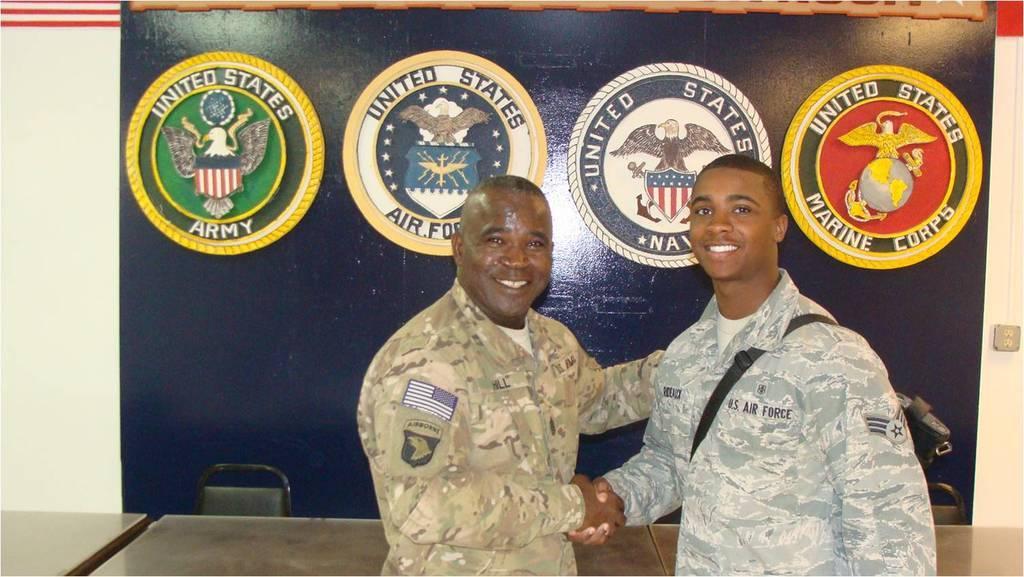How would you summarize this image in a sentence or two? In this image, I can see two persons standing and smiling. They are hand shaking with each other. At the bottom of the image, there are tables and chairs. In the background, I can see emblems attached to a board. Behind the board there is a wall. 